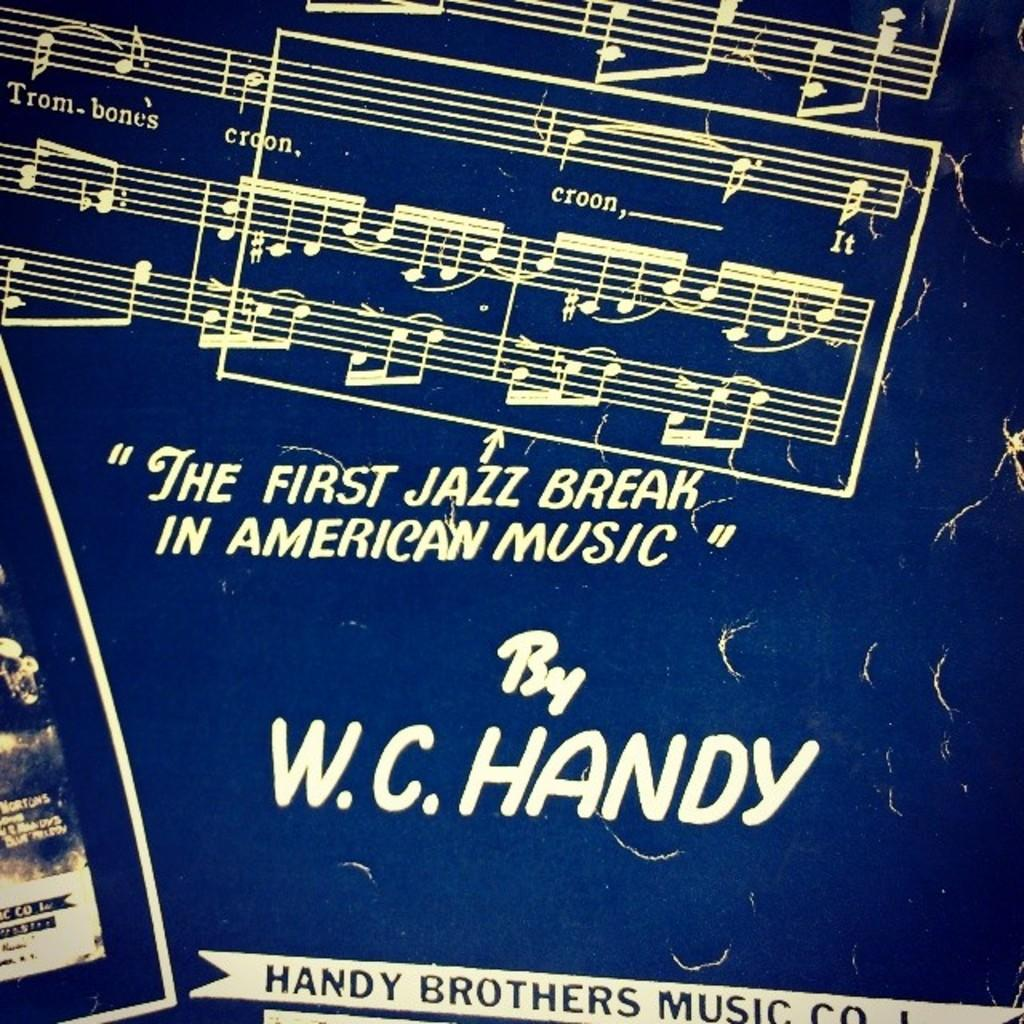<image>
Describe the image concisely. A poster says "The first jazz break in american music" by W.C. Handy on it 